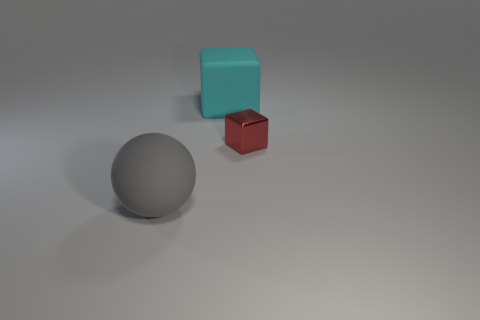Subtract all red blocks. How many blocks are left? 1 Subtract 1 spheres. How many spheres are left? 0 Add 3 big cyan matte things. How many objects exist? 6 Subtract all cubes. How many objects are left? 1 Subtract all red cubes. Subtract all purple cylinders. How many cubes are left? 1 Subtract all large gray things. Subtract all yellow metal objects. How many objects are left? 2 Add 3 small shiny objects. How many small shiny objects are left? 4 Add 3 big gray things. How many big gray things exist? 4 Subtract 0 purple cylinders. How many objects are left? 3 